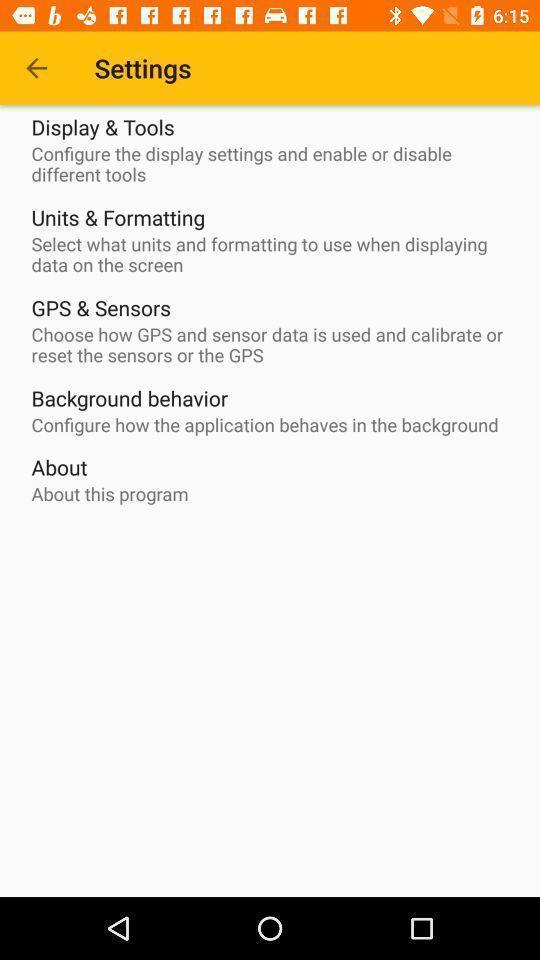Tell me about the visual elements in this screen capture. Setting page displaying various options. 